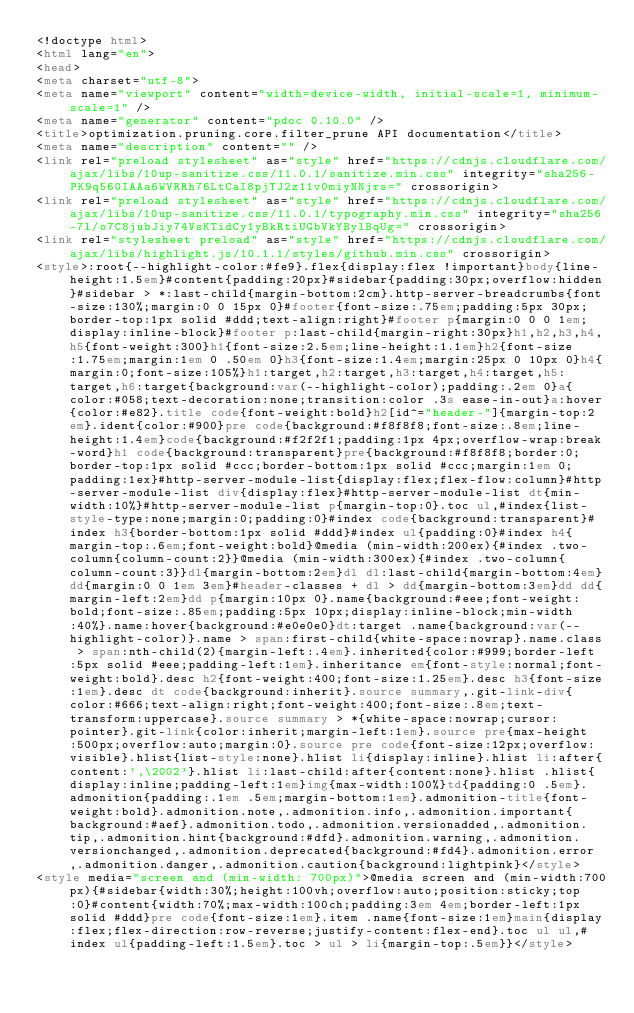<code> <loc_0><loc_0><loc_500><loc_500><_HTML_><!doctype html>
<html lang="en">
<head>
<meta charset="utf-8">
<meta name="viewport" content="width=device-width, initial-scale=1, minimum-scale=1" />
<meta name="generator" content="pdoc 0.10.0" />
<title>optimization.pruning.core.filter_prune API documentation</title>
<meta name="description" content="" />
<link rel="preload stylesheet" as="style" href="https://cdnjs.cloudflare.com/ajax/libs/10up-sanitize.css/11.0.1/sanitize.min.css" integrity="sha256-PK9q560IAAa6WVRRh76LtCaI8pjTJ2z11v0miyNNjrs=" crossorigin>
<link rel="preload stylesheet" as="style" href="https://cdnjs.cloudflare.com/ajax/libs/10up-sanitize.css/11.0.1/typography.min.css" integrity="sha256-7l/o7C8jubJiy74VsKTidCy1yBkRtiUGbVkYBylBqUg=" crossorigin>
<link rel="stylesheet preload" as="style" href="https://cdnjs.cloudflare.com/ajax/libs/highlight.js/10.1.1/styles/github.min.css" crossorigin>
<style>:root{--highlight-color:#fe9}.flex{display:flex !important}body{line-height:1.5em}#content{padding:20px}#sidebar{padding:30px;overflow:hidden}#sidebar > *:last-child{margin-bottom:2cm}.http-server-breadcrumbs{font-size:130%;margin:0 0 15px 0}#footer{font-size:.75em;padding:5px 30px;border-top:1px solid #ddd;text-align:right}#footer p{margin:0 0 0 1em;display:inline-block}#footer p:last-child{margin-right:30px}h1,h2,h3,h4,h5{font-weight:300}h1{font-size:2.5em;line-height:1.1em}h2{font-size:1.75em;margin:1em 0 .50em 0}h3{font-size:1.4em;margin:25px 0 10px 0}h4{margin:0;font-size:105%}h1:target,h2:target,h3:target,h4:target,h5:target,h6:target{background:var(--highlight-color);padding:.2em 0}a{color:#058;text-decoration:none;transition:color .3s ease-in-out}a:hover{color:#e82}.title code{font-weight:bold}h2[id^="header-"]{margin-top:2em}.ident{color:#900}pre code{background:#f8f8f8;font-size:.8em;line-height:1.4em}code{background:#f2f2f1;padding:1px 4px;overflow-wrap:break-word}h1 code{background:transparent}pre{background:#f8f8f8;border:0;border-top:1px solid #ccc;border-bottom:1px solid #ccc;margin:1em 0;padding:1ex}#http-server-module-list{display:flex;flex-flow:column}#http-server-module-list div{display:flex}#http-server-module-list dt{min-width:10%}#http-server-module-list p{margin-top:0}.toc ul,#index{list-style-type:none;margin:0;padding:0}#index code{background:transparent}#index h3{border-bottom:1px solid #ddd}#index ul{padding:0}#index h4{margin-top:.6em;font-weight:bold}@media (min-width:200ex){#index .two-column{column-count:2}}@media (min-width:300ex){#index .two-column{column-count:3}}dl{margin-bottom:2em}dl dl:last-child{margin-bottom:4em}dd{margin:0 0 1em 3em}#header-classes + dl > dd{margin-bottom:3em}dd dd{margin-left:2em}dd p{margin:10px 0}.name{background:#eee;font-weight:bold;font-size:.85em;padding:5px 10px;display:inline-block;min-width:40%}.name:hover{background:#e0e0e0}dt:target .name{background:var(--highlight-color)}.name > span:first-child{white-space:nowrap}.name.class > span:nth-child(2){margin-left:.4em}.inherited{color:#999;border-left:5px solid #eee;padding-left:1em}.inheritance em{font-style:normal;font-weight:bold}.desc h2{font-weight:400;font-size:1.25em}.desc h3{font-size:1em}.desc dt code{background:inherit}.source summary,.git-link-div{color:#666;text-align:right;font-weight:400;font-size:.8em;text-transform:uppercase}.source summary > *{white-space:nowrap;cursor:pointer}.git-link{color:inherit;margin-left:1em}.source pre{max-height:500px;overflow:auto;margin:0}.source pre code{font-size:12px;overflow:visible}.hlist{list-style:none}.hlist li{display:inline}.hlist li:after{content:',\2002'}.hlist li:last-child:after{content:none}.hlist .hlist{display:inline;padding-left:1em}img{max-width:100%}td{padding:0 .5em}.admonition{padding:.1em .5em;margin-bottom:1em}.admonition-title{font-weight:bold}.admonition.note,.admonition.info,.admonition.important{background:#aef}.admonition.todo,.admonition.versionadded,.admonition.tip,.admonition.hint{background:#dfd}.admonition.warning,.admonition.versionchanged,.admonition.deprecated{background:#fd4}.admonition.error,.admonition.danger,.admonition.caution{background:lightpink}</style>
<style media="screen and (min-width: 700px)">@media screen and (min-width:700px){#sidebar{width:30%;height:100vh;overflow:auto;position:sticky;top:0}#content{width:70%;max-width:100ch;padding:3em 4em;border-left:1px solid #ddd}pre code{font-size:1em}.item .name{font-size:1em}main{display:flex;flex-direction:row-reverse;justify-content:flex-end}.toc ul ul,#index ul{padding-left:1.5em}.toc > ul > li{margin-top:.5em}}</style></code> 